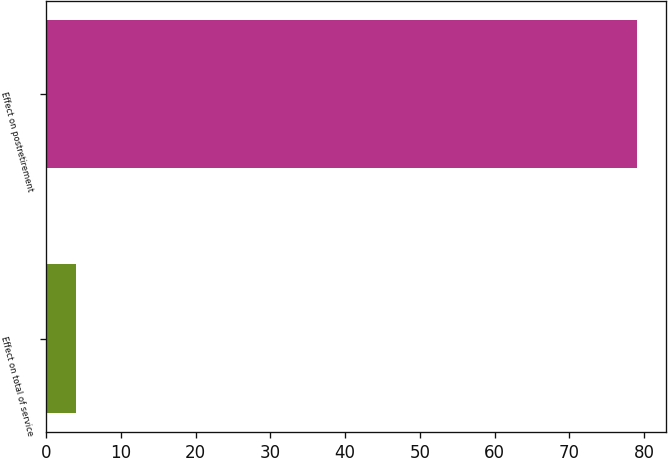<chart> <loc_0><loc_0><loc_500><loc_500><bar_chart><fcel>Effect on total of service<fcel>Effect on postretirement<nl><fcel>4<fcel>79<nl></chart> 